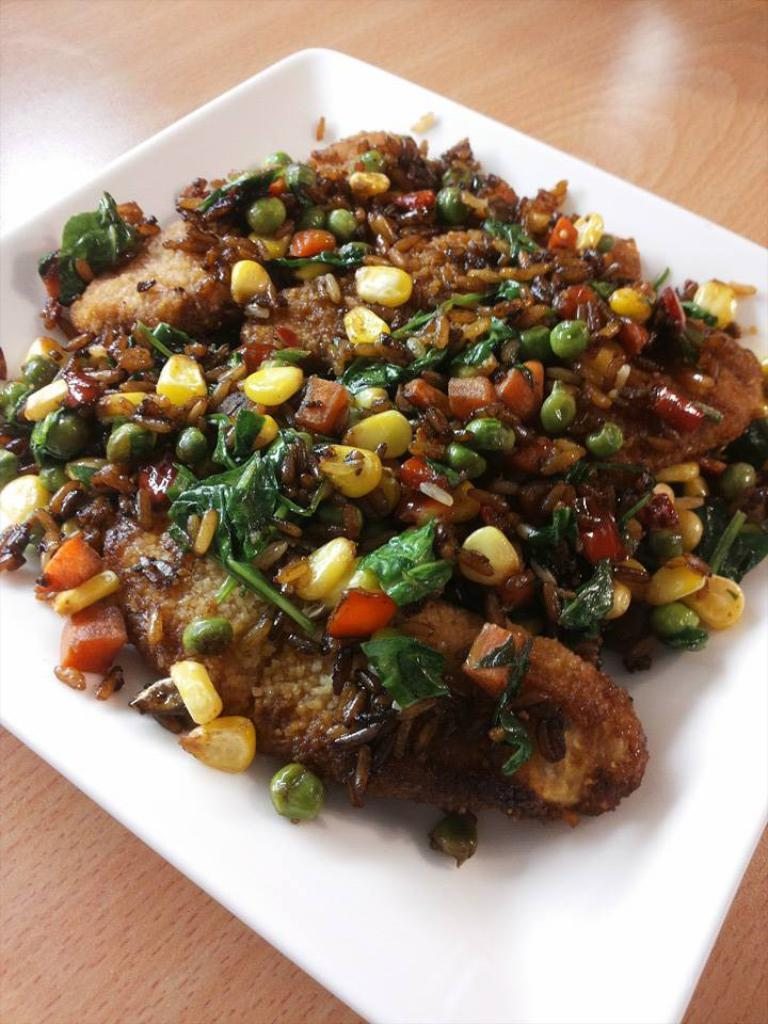What type of cooked food item can be seen in the image? There is a cooked food item in the image, but the specific type is not mentioned in the facts. How is the food item presented in the image? The food item is served on a white plate in the image. What type of garnish is used on the food item? The food is garnished with peas, corn, carrots, and other vegetables in the image. Reasoning: Let' Let's think step by step in order to produce the conversation. We start by acknowledging the presence of a cooked food item in the image, but we cannot specify the type without additional information. Next, we describe how the food item is presented, which is on a white plate. Finally, we mention the various types of garnish used on the food item, which include peas, corn, carrots, and other vegetables. Absurd Question/Answer: What type of chain is draped over the food item in the image? There is no chain present in the image; the food item is garnished with vegetables. Is the scarf used as a garnish on the food item in the image? No, there is no scarf present in the image; the food item is garnished with vegetables. What type of shirt is visible on the food item in the image? There is no shirt present in the image; the food item is garnished with vegetables. 